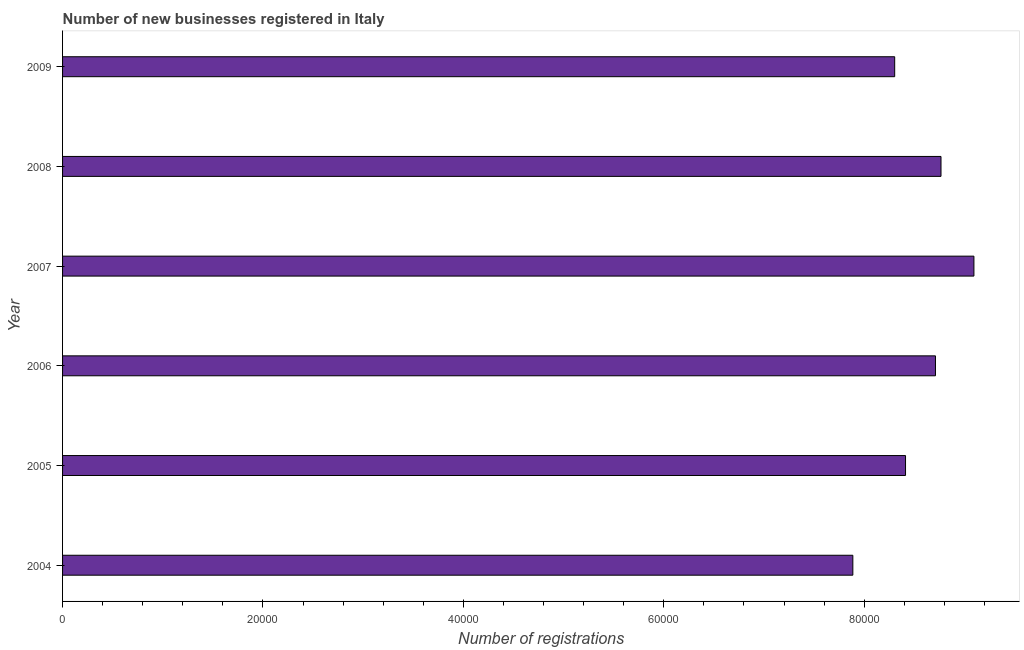Does the graph contain grids?
Make the answer very short. No. What is the title of the graph?
Make the answer very short. Number of new businesses registered in Italy. What is the label or title of the X-axis?
Offer a very short reply. Number of registrations. What is the number of new business registrations in 2005?
Make the answer very short. 8.41e+04. Across all years, what is the maximum number of new business registrations?
Offer a very short reply. 9.10e+04. Across all years, what is the minimum number of new business registrations?
Your response must be concise. 7.89e+04. What is the sum of the number of new business registrations?
Keep it short and to the point. 5.12e+05. What is the difference between the number of new business registrations in 2007 and 2009?
Keep it short and to the point. 7908. What is the average number of new business registrations per year?
Make the answer very short. 8.53e+04. What is the median number of new business registrations?
Offer a terse response. 8.56e+04. Do a majority of the years between 2008 and 2005 (inclusive) have number of new business registrations greater than 28000 ?
Make the answer very short. Yes. What is the ratio of the number of new business registrations in 2005 to that in 2007?
Provide a short and direct response. 0.93. What is the difference between the highest and the second highest number of new business registrations?
Provide a succinct answer. 3285. Is the sum of the number of new business registrations in 2005 and 2007 greater than the maximum number of new business registrations across all years?
Give a very brief answer. Yes. What is the difference between the highest and the lowest number of new business registrations?
Your answer should be very brief. 1.21e+04. In how many years, is the number of new business registrations greater than the average number of new business registrations taken over all years?
Your response must be concise. 3. How many bars are there?
Provide a short and direct response. 6. Are all the bars in the graph horizontal?
Make the answer very short. Yes. How many years are there in the graph?
Your response must be concise. 6. Are the values on the major ticks of X-axis written in scientific E-notation?
Your answer should be very brief. No. What is the Number of registrations of 2004?
Your response must be concise. 7.89e+04. What is the Number of registrations in 2005?
Offer a very short reply. 8.41e+04. What is the Number of registrations of 2006?
Your response must be concise. 8.71e+04. What is the Number of registrations of 2007?
Your response must be concise. 9.10e+04. What is the Number of registrations in 2008?
Ensure brevity in your answer.  8.77e+04. What is the Number of registrations of 2009?
Offer a very short reply. 8.30e+04. What is the difference between the Number of registrations in 2004 and 2005?
Your response must be concise. -5258. What is the difference between the Number of registrations in 2004 and 2006?
Your answer should be compact. -8246. What is the difference between the Number of registrations in 2004 and 2007?
Your answer should be compact. -1.21e+04. What is the difference between the Number of registrations in 2004 and 2008?
Your response must be concise. -8798. What is the difference between the Number of registrations in 2004 and 2009?
Provide a succinct answer. -4175. What is the difference between the Number of registrations in 2005 and 2006?
Make the answer very short. -2988. What is the difference between the Number of registrations in 2005 and 2007?
Ensure brevity in your answer.  -6825. What is the difference between the Number of registrations in 2005 and 2008?
Ensure brevity in your answer.  -3540. What is the difference between the Number of registrations in 2005 and 2009?
Provide a succinct answer. 1083. What is the difference between the Number of registrations in 2006 and 2007?
Make the answer very short. -3837. What is the difference between the Number of registrations in 2006 and 2008?
Make the answer very short. -552. What is the difference between the Number of registrations in 2006 and 2009?
Your response must be concise. 4071. What is the difference between the Number of registrations in 2007 and 2008?
Provide a succinct answer. 3285. What is the difference between the Number of registrations in 2007 and 2009?
Your answer should be compact. 7908. What is the difference between the Number of registrations in 2008 and 2009?
Your answer should be very brief. 4623. What is the ratio of the Number of registrations in 2004 to that in 2005?
Provide a short and direct response. 0.94. What is the ratio of the Number of registrations in 2004 to that in 2006?
Give a very brief answer. 0.91. What is the ratio of the Number of registrations in 2004 to that in 2007?
Your answer should be compact. 0.87. What is the ratio of the Number of registrations in 2004 to that in 2008?
Your answer should be very brief. 0.9. What is the ratio of the Number of registrations in 2004 to that in 2009?
Your answer should be compact. 0.95. What is the ratio of the Number of registrations in 2005 to that in 2006?
Provide a short and direct response. 0.97. What is the ratio of the Number of registrations in 2005 to that in 2007?
Offer a terse response. 0.93. What is the ratio of the Number of registrations in 2005 to that in 2008?
Your response must be concise. 0.96. What is the ratio of the Number of registrations in 2006 to that in 2007?
Offer a terse response. 0.96. What is the ratio of the Number of registrations in 2006 to that in 2009?
Keep it short and to the point. 1.05. What is the ratio of the Number of registrations in 2007 to that in 2008?
Ensure brevity in your answer.  1.04. What is the ratio of the Number of registrations in 2007 to that in 2009?
Make the answer very short. 1.09. What is the ratio of the Number of registrations in 2008 to that in 2009?
Offer a terse response. 1.06. 